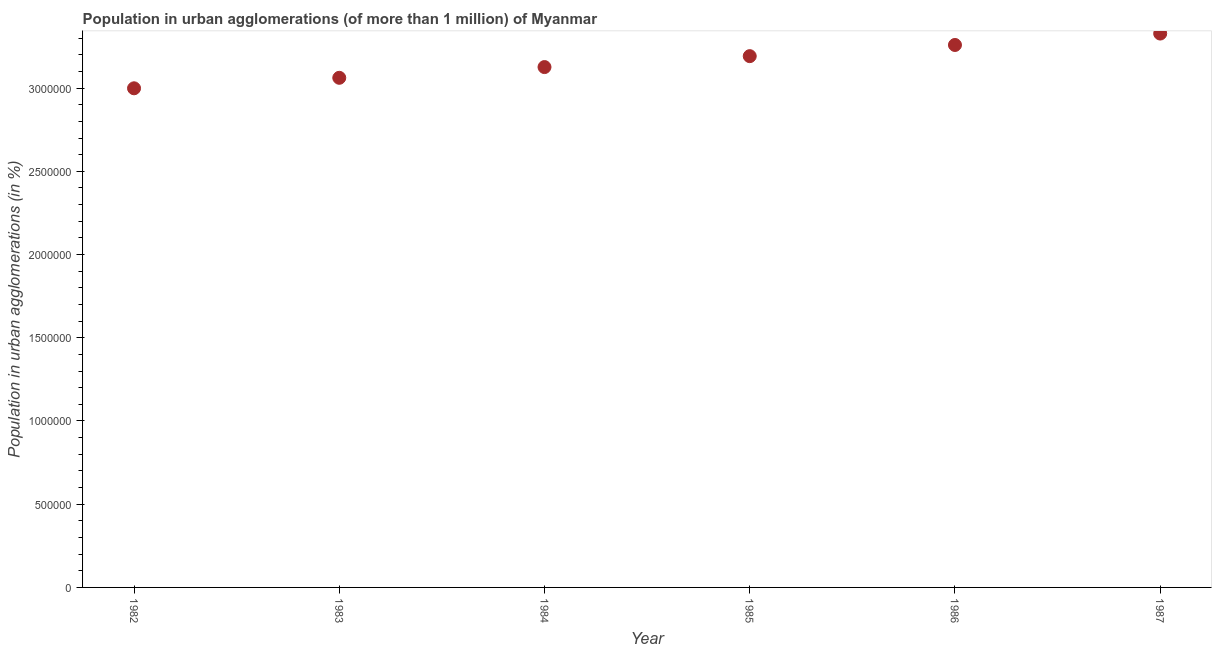What is the population in urban agglomerations in 1982?
Ensure brevity in your answer.  3.00e+06. Across all years, what is the maximum population in urban agglomerations?
Offer a very short reply. 3.33e+06. Across all years, what is the minimum population in urban agglomerations?
Give a very brief answer. 3.00e+06. In which year was the population in urban agglomerations maximum?
Your response must be concise. 1987. What is the sum of the population in urban agglomerations?
Provide a succinct answer. 1.90e+07. What is the difference between the population in urban agglomerations in 1982 and 1987?
Give a very brief answer. -3.29e+05. What is the average population in urban agglomerations per year?
Offer a very short reply. 3.16e+06. What is the median population in urban agglomerations?
Your answer should be compact. 3.16e+06. Do a majority of the years between 1986 and 1985 (inclusive) have population in urban agglomerations greater than 300000 %?
Offer a terse response. No. What is the ratio of the population in urban agglomerations in 1984 to that in 1987?
Ensure brevity in your answer.  0.94. Is the population in urban agglomerations in 1983 less than that in 1984?
Provide a short and direct response. Yes. Is the difference between the population in urban agglomerations in 1985 and 1986 greater than the difference between any two years?
Provide a short and direct response. No. What is the difference between the highest and the second highest population in urban agglomerations?
Offer a very short reply. 6.86e+04. What is the difference between the highest and the lowest population in urban agglomerations?
Offer a very short reply. 3.29e+05. In how many years, is the population in urban agglomerations greater than the average population in urban agglomerations taken over all years?
Ensure brevity in your answer.  3. Does the population in urban agglomerations monotonically increase over the years?
Your response must be concise. Yes. How many dotlines are there?
Provide a succinct answer. 1. Does the graph contain grids?
Keep it short and to the point. No. What is the title of the graph?
Offer a terse response. Population in urban agglomerations (of more than 1 million) of Myanmar. What is the label or title of the Y-axis?
Ensure brevity in your answer.  Population in urban agglomerations (in %). What is the Population in urban agglomerations (in %) in 1982?
Provide a short and direct response. 3.00e+06. What is the Population in urban agglomerations (in %) in 1983?
Your answer should be very brief. 3.06e+06. What is the Population in urban agglomerations (in %) in 1984?
Offer a terse response. 3.13e+06. What is the Population in urban agglomerations (in %) in 1985?
Offer a terse response. 3.19e+06. What is the Population in urban agglomerations (in %) in 1986?
Your answer should be compact. 3.26e+06. What is the Population in urban agglomerations (in %) in 1987?
Offer a terse response. 3.33e+06. What is the difference between the Population in urban agglomerations (in %) in 1982 and 1983?
Make the answer very short. -6.30e+04. What is the difference between the Population in urban agglomerations (in %) in 1982 and 1984?
Offer a terse response. -1.28e+05. What is the difference between the Population in urban agglomerations (in %) in 1982 and 1985?
Keep it short and to the point. -1.93e+05. What is the difference between the Population in urban agglomerations (in %) in 1982 and 1986?
Your answer should be very brief. -2.60e+05. What is the difference between the Population in urban agglomerations (in %) in 1982 and 1987?
Offer a terse response. -3.29e+05. What is the difference between the Population in urban agglomerations (in %) in 1983 and 1984?
Keep it short and to the point. -6.45e+04. What is the difference between the Population in urban agglomerations (in %) in 1983 and 1985?
Provide a succinct answer. -1.30e+05. What is the difference between the Population in urban agglomerations (in %) in 1983 and 1986?
Your answer should be compact. -1.97e+05. What is the difference between the Population in urban agglomerations (in %) in 1983 and 1987?
Ensure brevity in your answer.  -2.66e+05. What is the difference between the Population in urban agglomerations (in %) in 1984 and 1985?
Provide a short and direct response. -6.57e+04. What is the difference between the Population in urban agglomerations (in %) in 1984 and 1986?
Your response must be concise. -1.33e+05. What is the difference between the Population in urban agglomerations (in %) in 1984 and 1987?
Make the answer very short. -2.01e+05. What is the difference between the Population in urban agglomerations (in %) in 1985 and 1986?
Offer a very short reply. -6.71e+04. What is the difference between the Population in urban agglomerations (in %) in 1985 and 1987?
Your response must be concise. -1.36e+05. What is the difference between the Population in urban agglomerations (in %) in 1986 and 1987?
Ensure brevity in your answer.  -6.86e+04. What is the ratio of the Population in urban agglomerations (in %) in 1982 to that in 1984?
Your response must be concise. 0.96. What is the ratio of the Population in urban agglomerations (in %) in 1982 to that in 1985?
Ensure brevity in your answer.  0.94. What is the ratio of the Population in urban agglomerations (in %) in 1982 to that in 1987?
Offer a terse response. 0.9. What is the ratio of the Population in urban agglomerations (in %) in 1983 to that in 1986?
Provide a succinct answer. 0.94. What is the ratio of the Population in urban agglomerations (in %) in 1983 to that in 1987?
Your answer should be compact. 0.92. What is the ratio of the Population in urban agglomerations (in %) in 1984 to that in 1987?
Offer a terse response. 0.94. What is the ratio of the Population in urban agglomerations (in %) in 1985 to that in 1986?
Your response must be concise. 0.98. What is the ratio of the Population in urban agglomerations (in %) in 1986 to that in 1987?
Provide a succinct answer. 0.98. 